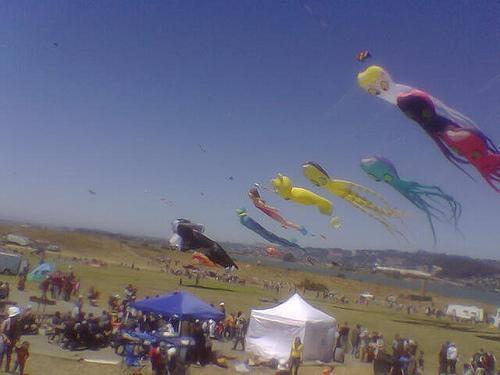How many large kites are in the sky?
Give a very brief answer. 8. How many tents are in this picture?
Give a very brief answer. 2. How many kites are there?
Give a very brief answer. 4. How many brown bench seats?
Give a very brief answer. 0. 